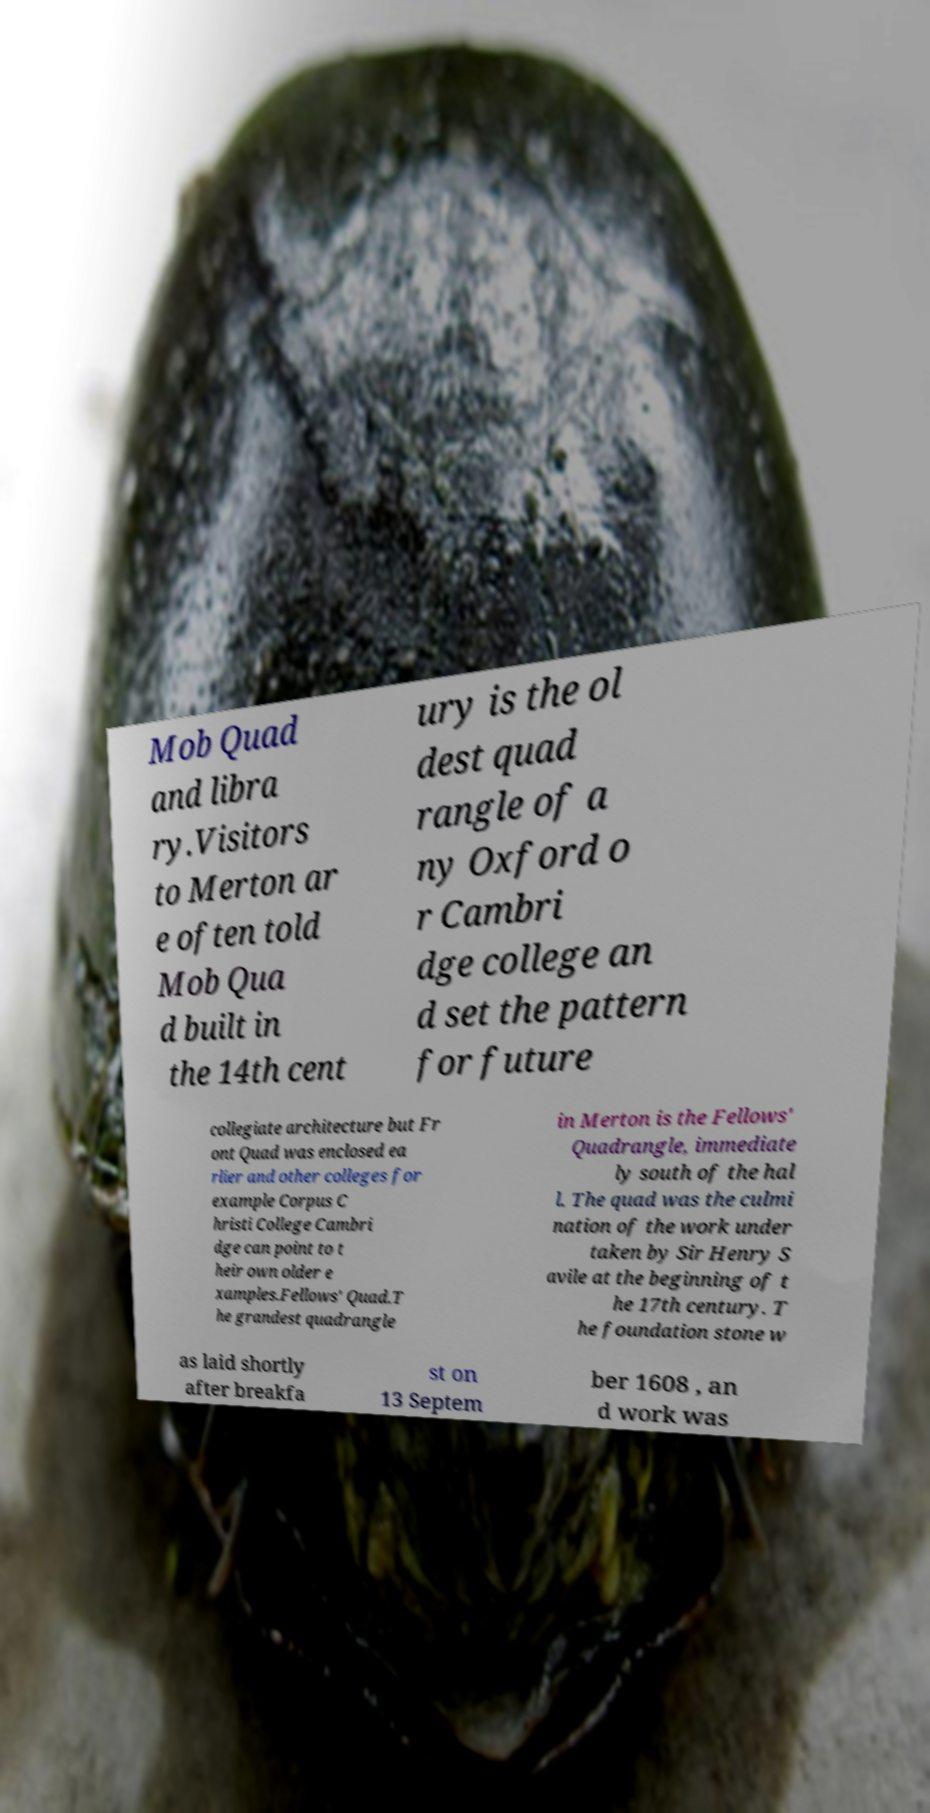For documentation purposes, I need the text within this image transcribed. Could you provide that? Mob Quad and libra ry.Visitors to Merton ar e often told Mob Qua d built in the 14th cent ury is the ol dest quad rangle of a ny Oxford o r Cambri dge college an d set the pattern for future collegiate architecture but Fr ont Quad was enclosed ea rlier and other colleges for example Corpus C hristi College Cambri dge can point to t heir own older e xamples.Fellows' Quad.T he grandest quadrangle in Merton is the Fellows' Quadrangle, immediate ly south of the hal l. The quad was the culmi nation of the work under taken by Sir Henry S avile at the beginning of t he 17th century. T he foundation stone w as laid shortly after breakfa st on 13 Septem ber 1608 , an d work was 